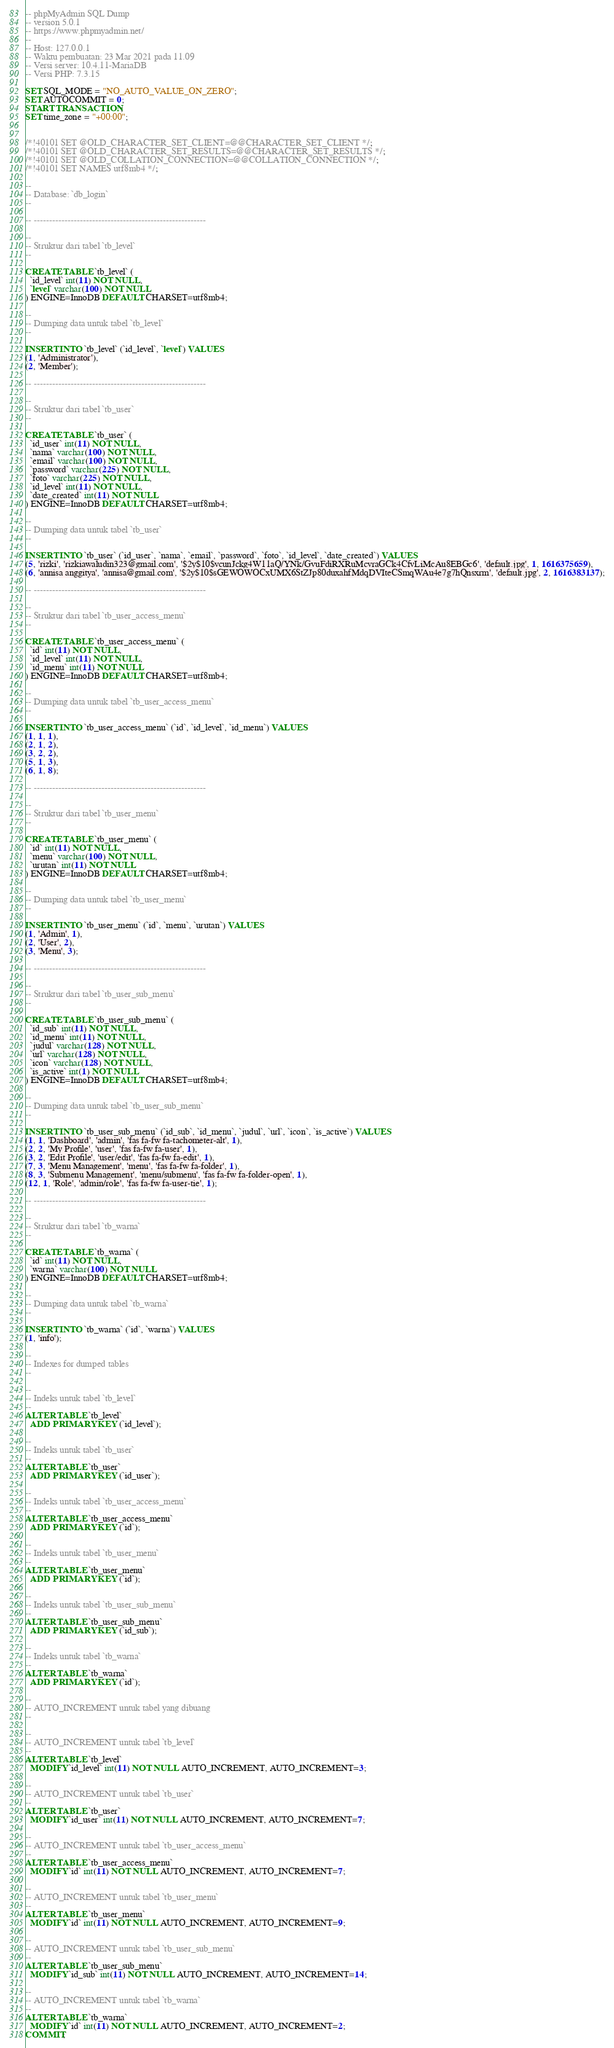<code> <loc_0><loc_0><loc_500><loc_500><_SQL_>-- phpMyAdmin SQL Dump
-- version 5.0.1
-- https://www.phpmyadmin.net/
--
-- Host: 127.0.0.1
-- Waktu pembuatan: 23 Mar 2021 pada 11.09
-- Versi server: 10.4.11-MariaDB
-- Versi PHP: 7.3.15

SET SQL_MODE = "NO_AUTO_VALUE_ON_ZERO";
SET AUTOCOMMIT = 0;
START TRANSACTION;
SET time_zone = "+00:00";


/*!40101 SET @OLD_CHARACTER_SET_CLIENT=@@CHARACTER_SET_CLIENT */;
/*!40101 SET @OLD_CHARACTER_SET_RESULTS=@@CHARACTER_SET_RESULTS */;
/*!40101 SET @OLD_COLLATION_CONNECTION=@@COLLATION_CONNECTION */;
/*!40101 SET NAMES utf8mb4 */;

--
-- Database: `db_login`
--

-- --------------------------------------------------------

--
-- Struktur dari tabel `tb_level`
--

CREATE TABLE `tb_level` (
  `id_level` int(11) NOT NULL,
  `level` varchar(100) NOT NULL
) ENGINE=InnoDB DEFAULT CHARSET=utf8mb4;

--
-- Dumping data untuk tabel `tb_level`
--

INSERT INTO `tb_level` (`id_level`, `level`) VALUES
(1, 'Administrator'),
(2, 'Member');

-- --------------------------------------------------------

--
-- Struktur dari tabel `tb_user`
--

CREATE TABLE `tb_user` (
  `id_user` int(11) NOT NULL,
  `nama` varchar(100) NOT NULL,
  `email` varchar(100) NOT NULL,
  `password` varchar(225) NOT NULL,
  `foto` varchar(225) NOT NULL,
  `id_level` int(11) NOT NULL,
  `date_created` int(11) NOT NULL
) ENGINE=InnoDB DEFAULT CHARSET=utf8mb4;

--
-- Dumping data untuk tabel `tb_user`
--

INSERT INTO `tb_user` (`id_user`, `nama`, `email`, `password`, `foto`, `id_level`, `date_created`) VALUES
(5, 'rizki', 'rizkiawaludin323@gmail.com', '$2y$10$vcunJckg4W11aQ/YNk/GvuFdiRXRuMcvraGCk4CfvLiMcAu8EBGc6', 'default.jpg', 1, 1616375659),
(6, 'annisa anggitya', 'annisa@gmail.com', '$2y$10$sGEWOWOCxUMX6StZJp80duxahfMdqDVIteCSmqWAu4e7g7hQnsxrm', 'default.jpg', 2, 1616383137);

-- --------------------------------------------------------

--
-- Struktur dari tabel `tb_user_access_menu`
--

CREATE TABLE `tb_user_access_menu` (
  `id` int(11) NOT NULL,
  `id_level` int(11) NOT NULL,
  `id_menu` int(11) NOT NULL
) ENGINE=InnoDB DEFAULT CHARSET=utf8mb4;

--
-- Dumping data untuk tabel `tb_user_access_menu`
--

INSERT INTO `tb_user_access_menu` (`id`, `id_level`, `id_menu`) VALUES
(1, 1, 1),
(2, 1, 2),
(3, 2, 2),
(5, 1, 3),
(6, 1, 8);

-- --------------------------------------------------------

--
-- Struktur dari tabel `tb_user_menu`
--

CREATE TABLE `tb_user_menu` (
  `id` int(11) NOT NULL,
  `menu` varchar(100) NOT NULL,
  `urutan` int(11) NOT NULL
) ENGINE=InnoDB DEFAULT CHARSET=utf8mb4;

--
-- Dumping data untuk tabel `tb_user_menu`
--

INSERT INTO `tb_user_menu` (`id`, `menu`, `urutan`) VALUES
(1, 'Admin', 1),
(2, 'User', 2),
(3, 'Menu', 3);

-- --------------------------------------------------------

--
-- Struktur dari tabel `tb_user_sub_menu`
--

CREATE TABLE `tb_user_sub_menu` (
  `id_sub` int(11) NOT NULL,
  `id_menu` int(11) NOT NULL,
  `judul` varchar(128) NOT NULL,
  `url` varchar(128) NOT NULL,
  `icon` varchar(128) NOT NULL,
  `is_active` int(1) NOT NULL
) ENGINE=InnoDB DEFAULT CHARSET=utf8mb4;

--
-- Dumping data untuk tabel `tb_user_sub_menu`
--

INSERT INTO `tb_user_sub_menu` (`id_sub`, `id_menu`, `judul`, `url`, `icon`, `is_active`) VALUES
(1, 1, 'Dashboard', 'admin', 'fas fa-fw fa-tachometer-alt', 1),
(2, 2, 'My Profile', 'user', 'fas fa-fw fa-user', 1),
(3, 2, 'Edit Profile', 'user/edit', 'fas fa-fw fa-edit', 1),
(7, 3, 'Menu Management', 'menu', 'fas fa-fw fa-folder', 1),
(8, 3, 'Submenu Management', 'menu/submenu', 'fas fa-fw fa-folder-open', 1),
(12, 1, 'Role', 'admin/role', 'fas fa-fw fa-user-tie', 1);

-- --------------------------------------------------------

--
-- Struktur dari tabel `tb_warna`
--

CREATE TABLE `tb_warna` (
  `id` int(11) NOT NULL,
  `warna` varchar(100) NOT NULL
) ENGINE=InnoDB DEFAULT CHARSET=utf8mb4;

--
-- Dumping data untuk tabel `tb_warna`
--

INSERT INTO `tb_warna` (`id`, `warna`) VALUES
(1, 'info');

--
-- Indexes for dumped tables
--

--
-- Indeks untuk tabel `tb_level`
--
ALTER TABLE `tb_level`
  ADD PRIMARY KEY (`id_level`);

--
-- Indeks untuk tabel `tb_user`
--
ALTER TABLE `tb_user`
  ADD PRIMARY KEY (`id_user`);

--
-- Indeks untuk tabel `tb_user_access_menu`
--
ALTER TABLE `tb_user_access_menu`
  ADD PRIMARY KEY (`id`);

--
-- Indeks untuk tabel `tb_user_menu`
--
ALTER TABLE `tb_user_menu`
  ADD PRIMARY KEY (`id`);

--
-- Indeks untuk tabel `tb_user_sub_menu`
--
ALTER TABLE `tb_user_sub_menu`
  ADD PRIMARY KEY (`id_sub`);

--
-- Indeks untuk tabel `tb_warna`
--
ALTER TABLE `tb_warna`
  ADD PRIMARY KEY (`id`);

--
-- AUTO_INCREMENT untuk tabel yang dibuang
--

--
-- AUTO_INCREMENT untuk tabel `tb_level`
--
ALTER TABLE `tb_level`
  MODIFY `id_level` int(11) NOT NULL AUTO_INCREMENT, AUTO_INCREMENT=3;

--
-- AUTO_INCREMENT untuk tabel `tb_user`
--
ALTER TABLE `tb_user`
  MODIFY `id_user` int(11) NOT NULL AUTO_INCREMENT, AUTO_INCREMENT=7;

--
-- AUTO_INCREMENT untuk tabel `tb_user_access_menu`
--
ALTER TABLE `tb_user_access_menu`
  MODIFY `id` int(11) NOT NULL AUTO_INCREMENT, AUTO_INCREMENT=7;

--
-- AUTO_INCREMENT untuk tabel `tb_user_menu`
--
ALTER TABLE `tb_user_menu`
  MODIFY `id` int(11) NOT NULL AUTO_INCREMENT, AUTO_INCREMENT=9;

--
-- AUTO_INCREMENT untuk tabel `tb_user_sub_menu`
--
ALTER TABLE `tb_user_sub_menu`
  MODIFY `id_sub` int(11) NOT NULL AUTO_INCREMENT, AUTO_INCREMENT=14;

--
-- AUTO_INCREMENT untuk tabel `tb_warna`
--
ALTER TABLE `tb_warna`
  MODIFY `id` int(11) NOT NULL AUTO_INCREMENT, AUTO_INCREMENT=2;
COMMIT;
</code> 